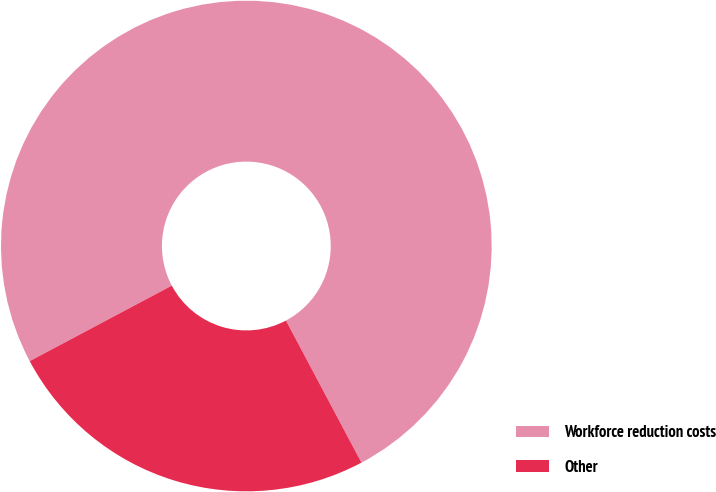<chart> <loc_0><loc_0><loc_500><loc_500><pie_chart><fcel>Workforce reduction costs<fcel>Other<nl><fcel>75.0%<fcel>25.0%<nl></chart> 